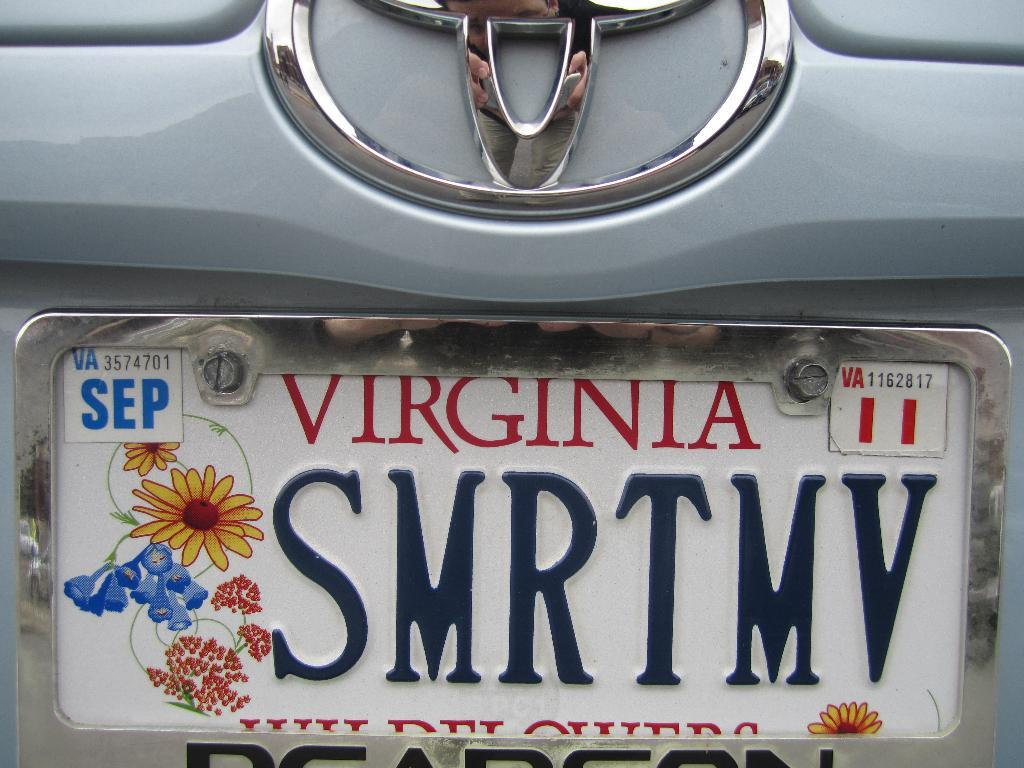<image>
Offer a succinct explanation of the picture presented. The back of a silver colored vehicle with a virginia state license plate hanging on it. 